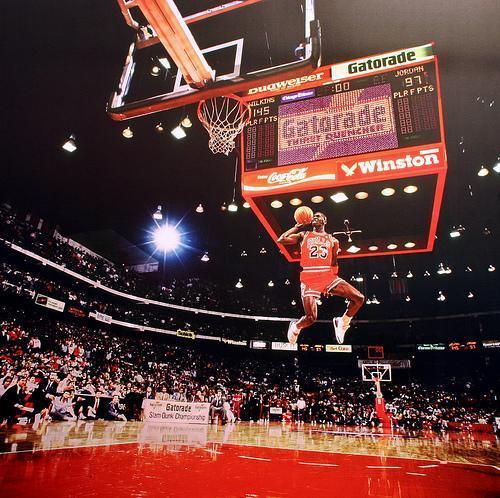How many people are in the air?
Give a very brief answer. 1. 